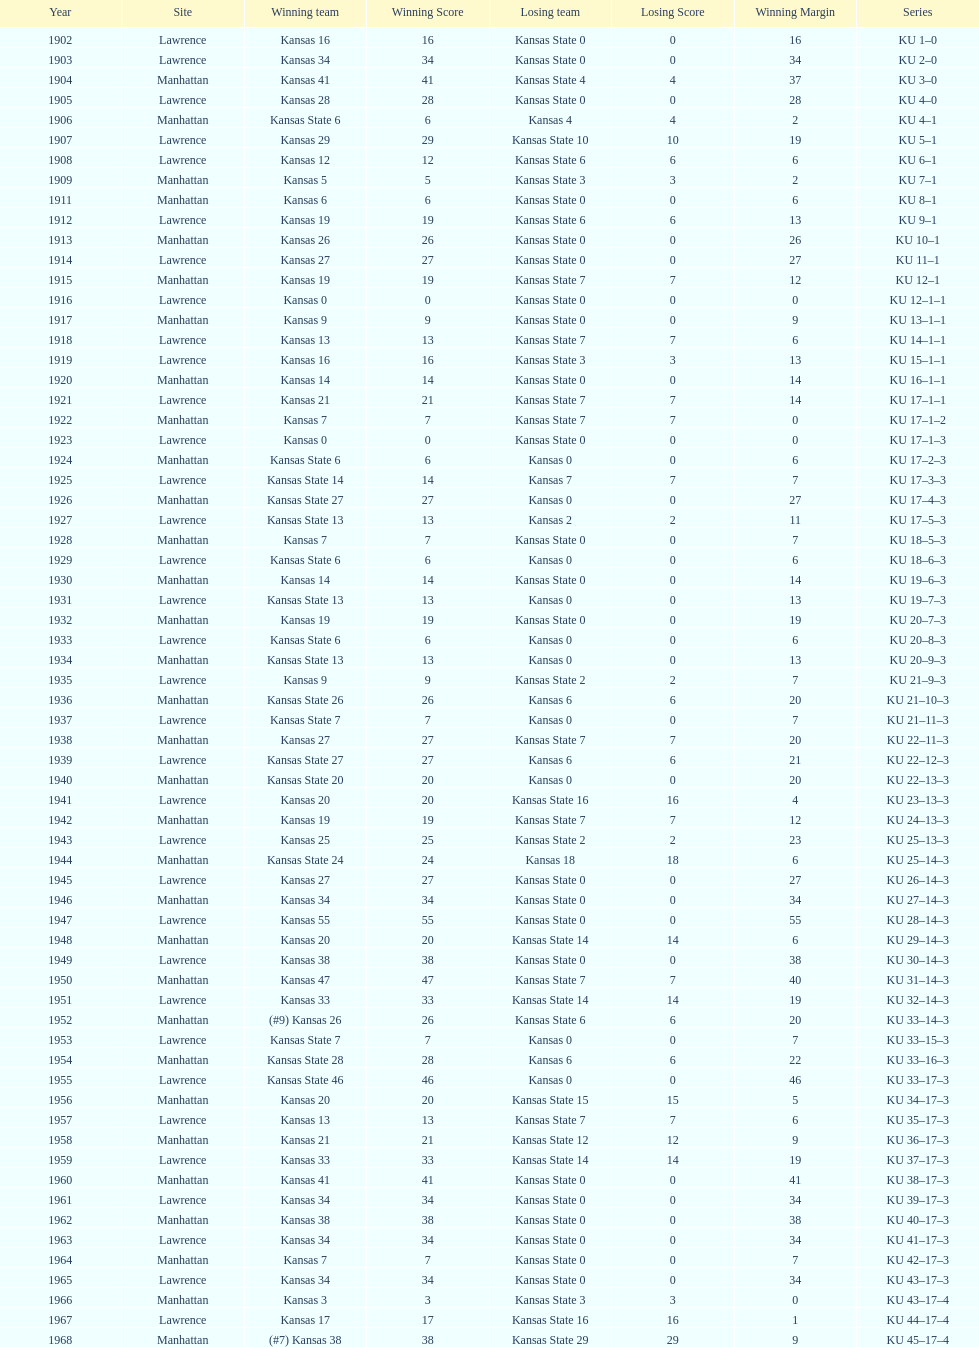How many times did kansas state not score at all against kansas from 1902-1968? 23. 